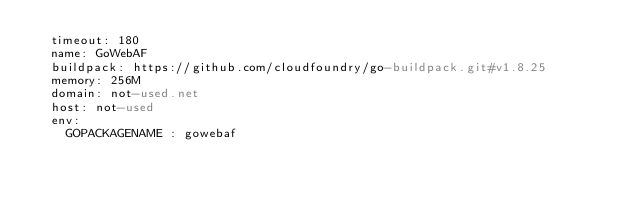Convert code to text. <code><loc_0><loc_0><loc_500><loc_500><_YAML_>  timeout: 180
  name: GoWebAF
  buildpack: https://github.com/cloudfoundry/go-buildpack.git#v1.8.25
  memory: 256M
  domain: not-used.net
  host: not-used
  env:
    GOPACKAGENAME : gowebaf
</code> 